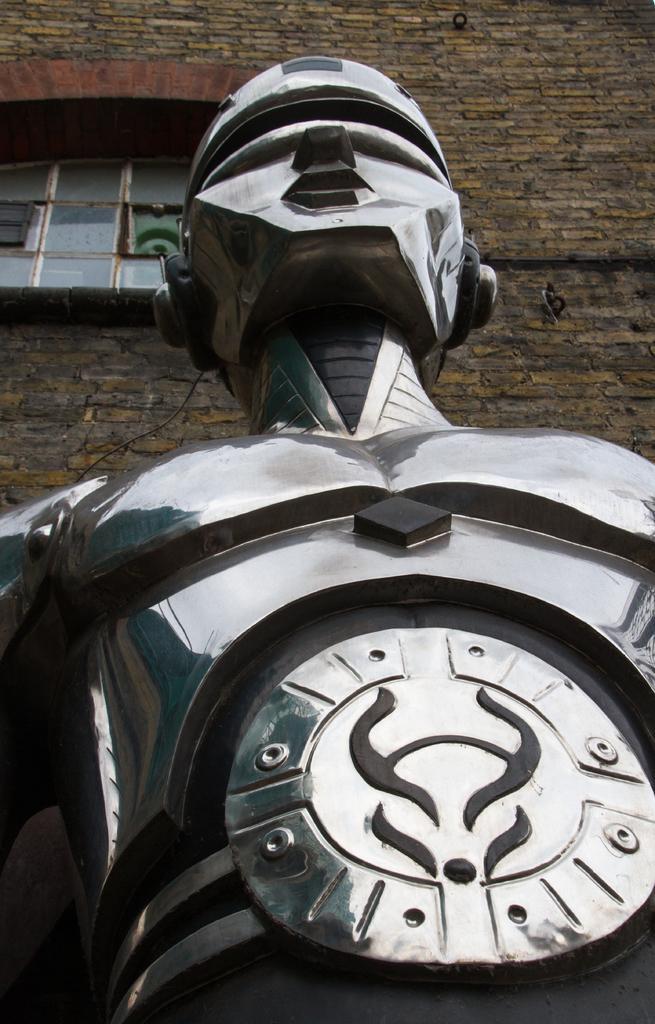Can you describe this image briefly? In the image there is a metal statue in the front and behind it there is a building. 